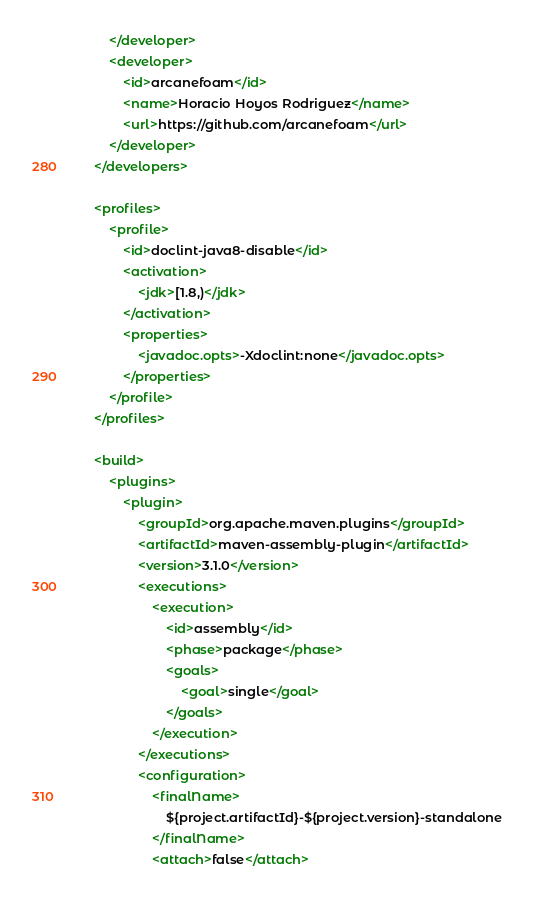<code> <loc_0><loc_0><loc_500><loc_500><_XML_>		</developer>
		<developer>
			<id>arcanefoam</id>
			<name>Horacio Hoyos Rodriguez</name>
			<url>https://github.com/arcanefoam</url>
		</developer>
	</developers>

	<profiles>
		<profile>
			<id>doclint-java8-disable</id>
			<activation>
				<jdk>[1.8,)</jdk>
			</activation>
			<properties>
				<javadoc.opts>-Xdoclint:none</javadoc.opts>
			</properties>
		</profile>
	</profiles>

	<build>
		<plugins>
			<plugin>
				<groupId>org.apache.maven.plugins</groupId>
				<artifactId>maven-assembly-plugin</artifactId>
				<version>3.1.0</version>
				<executions>
					<execution>
						<id>assembly</id>
						<phase>package</phase>
						<goals>
							<goal>single</goal>
						</goals>
					</execution>
				</executions>
				<configuration>
					<finalName>
						${project.artifactId}-${project.version}-standalone
					</finalName>
					<attach>false</attach></code> 